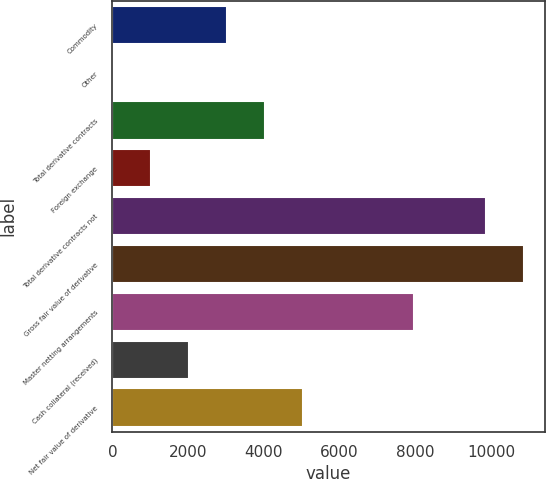Convert chart to OTSL. <chart><loc_0><loc_0><loc_500><loc_500><bar_chart><fcel>Commodity<fcel>Other<fcel>Total derivative contracts<fcel>Foreign exchange<fcel>Total derivative contracts not<fcel>Gross fair value of derivative<fcel>Master netting arrangements<fcel>Cash collateral (received)<fcel>Net fair value of derivative<nl><fcel>3028.2<fcel>3<fcel>4036.6<fcel>1011.4<fcel>9868<fcel>10876.4<fcel>7962<fcel>2019.8<fcel>5045<nl></chart> 